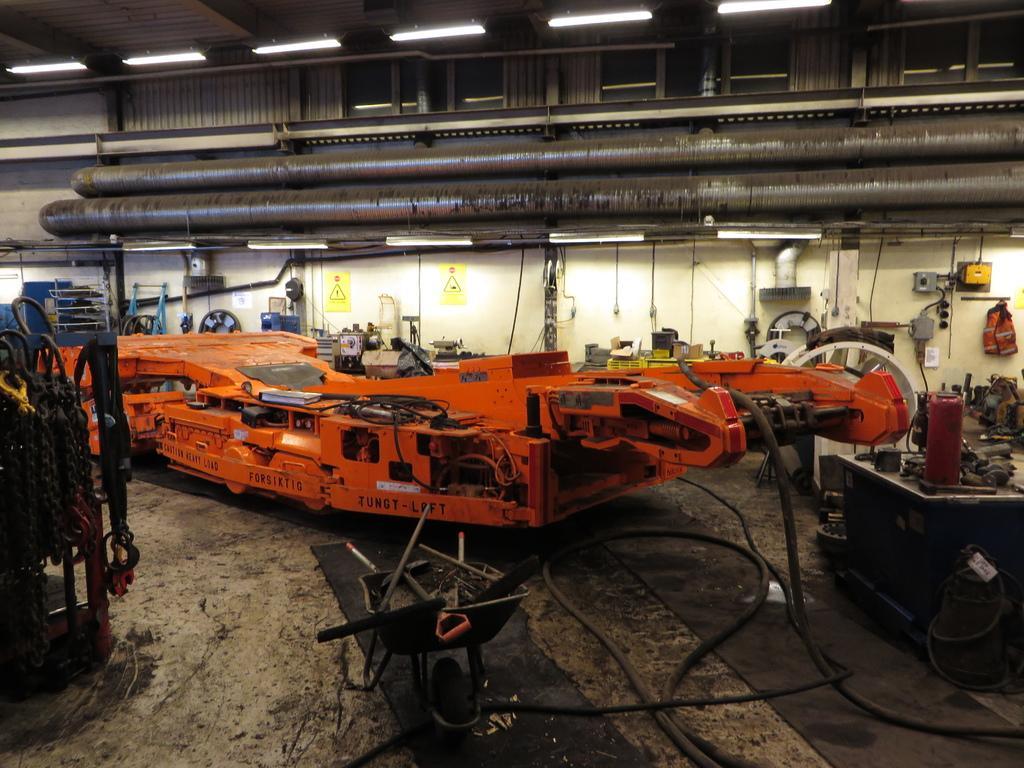How would you summarize this image in a sentence or two? This image consists of machines. It looks like a manufacturing unit. At the bottom, there is a floor. At the top, there is a roof along with lights. 